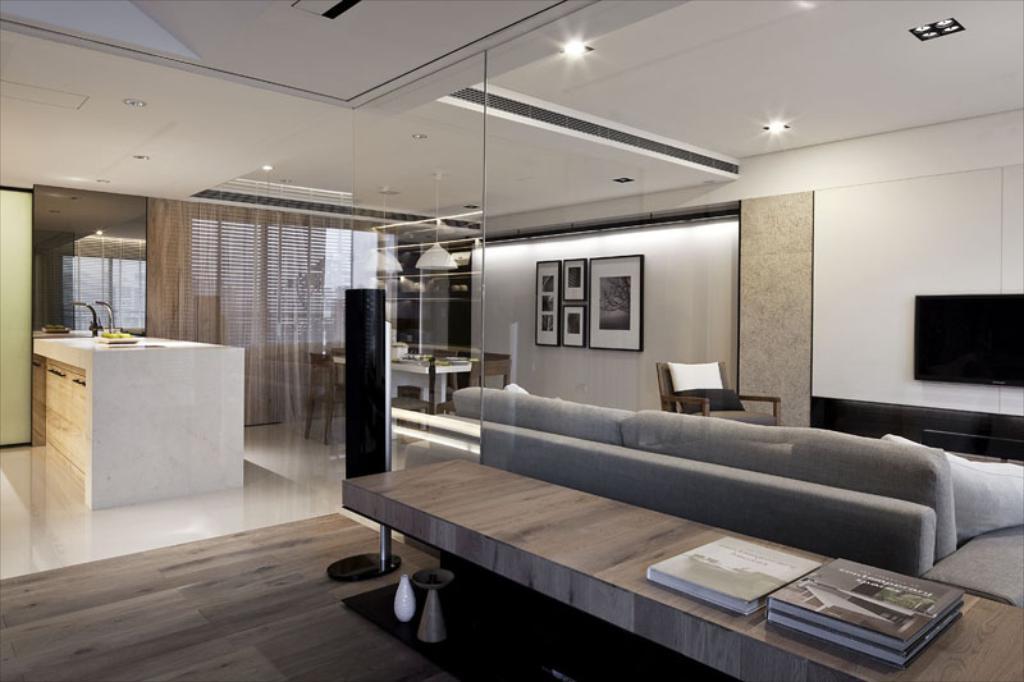Could you give a brief overview of what you see in this image? This image is taken inside a room. The room is fully furnished. In the right side of the image there is a television on a wall, sofa and a chair. In the left side of the image there is a floor and a shelf in kitchen. In the middle of the image there is a dining table. At the background there is a wall with frames. At the top of the image there is a ceiling with lights. In right side image there is a table on which there are few books. 